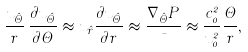<formula> <loc_0><loc_0><loc_500><loc_500>\frac { u _ { \hat { \Theta } } } { r } \, \frac { \partial u _ { \hat { \Theta } } } { \partial \Theta } \approx u _ { \hat { r } } \frac { \partial u _ { \hat { \Theta } } } { \partial r } \approx \frac { \nabla _ { \hat { \Theta } } P } { \mu } \approx \frac { c _ { 0 } ^ { 2 } } { u _ { 0 } ^ { 2 } } \frac { \Theta } { r } ,</formula> 